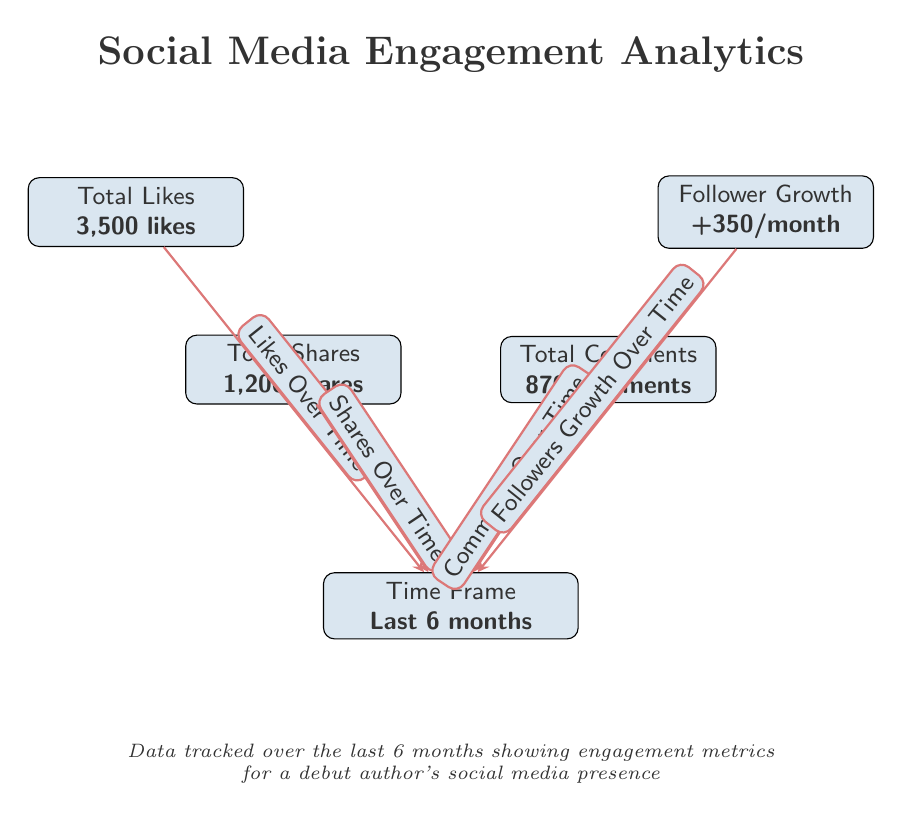What is the total number of likes? The diagram explicitly states the total likes as "3,500 likes," which can be found next to the "Total Likes" node.
Answer: 3,500 likes What is the total number of shares? The "Total Shares" node in the diagram indicates "1,200 shares." This is the value displayed directly in the node.
Answer: 1,200 shares How many comments are reported in the diagram? According to the "Total Comments" node, the figure is "870 comments," which is stated clearly within that node.
Answer: 870 comments What is the average follower growth per month? The "Follower Growth" node reveals that the average growth is "+350/month," as shown in the diagram directly next to that node.
Answer: +350/month What is the time frame for the data shown? The diagram mentions "Last 6 months" in the "Time Frame" node, providing a clear indication of the data's range.
Answer: Last 6 months What can you infer about the relationship between likes and shares? The diagram indicates that both "Likes Over Time" and "Shares Over Time" have arrows pointing towards the "Time Frame," suggesting these metrics are measured during the same period, facilitating a comparison of their trends over the last six months.
Answer: They are both measured over the same time frame How do the engagement metrics trend over the last six months? The arrows directing from likes, shares, comments, and followers towards "Time Frame" imply that these metrics track engagement over the same six-month period, indicating a coherent picture of social media activity over time.
Answer: They trend over the same six-month period Which metric has the highest numerical value? Examining the values presented for likes (3,500), shares (1,200), comments (870), and followers (+350), it's clear that the highest value is associated with likes.
Answer: Likes How many types of engagement metrics are displayed in the diagram? The diagram includes four distinct metrics: likes, shares, comments, and follower growth, identified as separate nodes connected to the time frame. Therefore, there are four types displayed.
Answer: Four types 